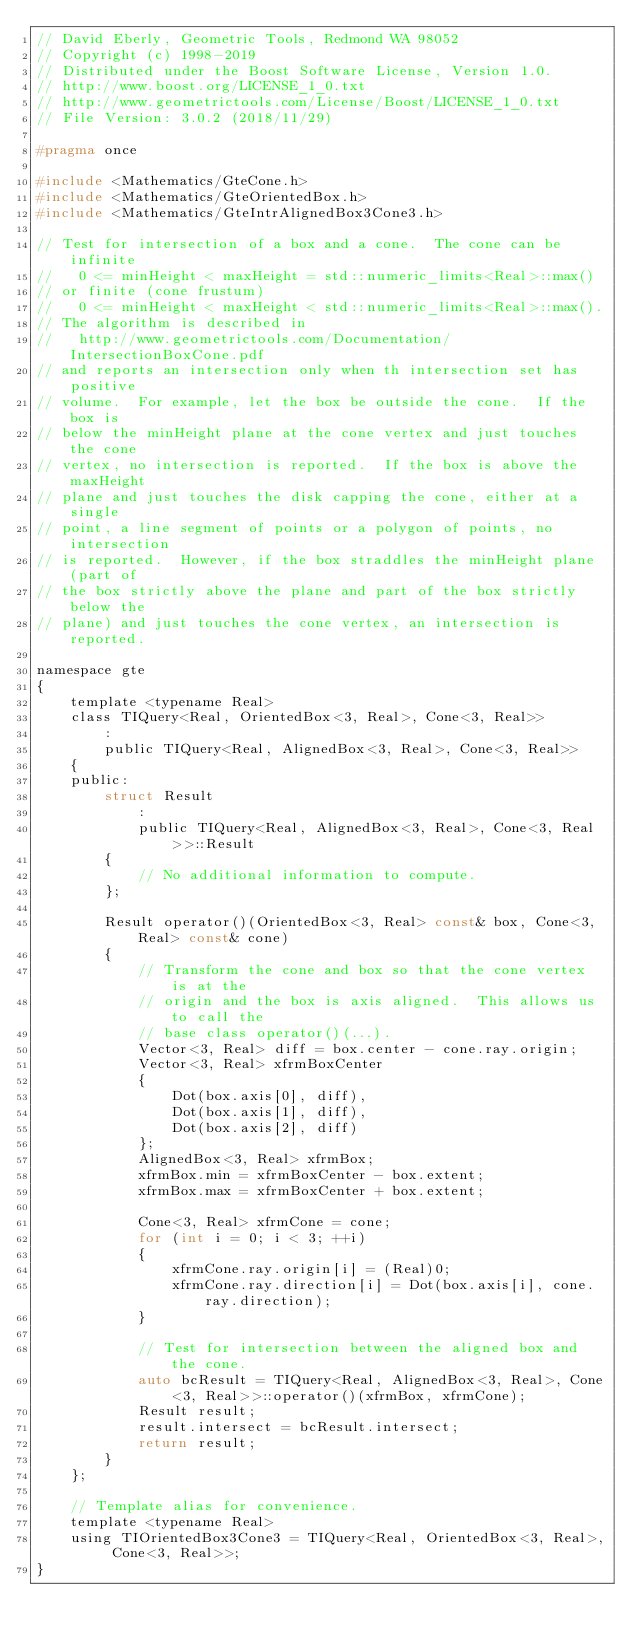<code> <loc_0><loc_0><loc_500><loc_500><_C_>// David Eberly, Geometric Tools, Redmond WA 98052
// Copyright (c) 1998-2019
// Distributed under the Boost Software License, Version 1.0.
// http://www.boost.org/LICENSE_1_0.txt
// http://www.geometrictools.com/License/Boost/LICENSE_1_0.txt
// File Version: 3.0.2 (2018/11/29)

#pragma once

#include <Mathematics/GteCone.h>
#include <Mathematics/GteOrientedBox.h>
#include <Mathematics/GteIntrAlignedBox3Cone3.h>

// Test for intersection of a box and a cone.  The cone can be infinite
//   0 <= minHeight < maxHeight = std::numeric_limits<Real>::max()
// or finite (cone frustum)
//   0 <= minHeight < maxHeight < std::numeric_limits<Real>::max().
// The algorithm is described in
//   http://www.geometrictools.com/Documentation/IntersectionBoxCone.pdf
// and reports an intersection only when th intersection set has positive
// volume.  For example, let the box be outside the cone.  If the box is
// below the minHeight plane at the cone vertex and just touches the cone
// vertex, no intersection is reported.  If the box is above the maxHeight
// plane and just touches the disk capping the cone, either at a single
// point, a line segment of points or a polygon of points, no intersection
// is reported.  However, if the box straddles the minHeight plane (part of
// the box strictly above the plane and part of the box strictly below the
// plane) and just touches the cone vertex, an intersection is reported.

namespace gte
{
    template <typename Real>
    class TIQuery<Real, OrientedBox<3, Real>, Cone<3, Real>>
        :
        public TIQuery<Real, AlignedBox<3, Real>, Cone<3, Real>>
    {
    public:
        struct Result
            :
            public TIQuery<Real, AlignedBox<3, Real>, Cone<3, Real>>::Result
        {
            // No additional information to compute.
        };

        Result operator()(OrientedBox<3, Real> const& box, Cone<3, Real> const& cone)
        {
            // Transform the cone and box so that the cone vertex is at the
            // origin and the box is axis aligned.  This allows us to call the
            // base class operator()(...).
            Vector<3, Real> diff = box.center - cone.ray.origin;
            Vector<3, Real> xfrmBoxCenter
            {
                Dot(box.axis[0], diff),
                Dot(box.axis[1], diff),
                Dot(box.axis[2], diff)
            };
            AlignedBox<3, Real> xfrmBox;
            xfrmBox.min = xfrmBoxCenter - box.extent;
            xfrmBox.max = xfrmBoxCenter + box.extent;

            Cone<3, Real> xfrmCone = cone;
            for (int i = 0; i < 3; ++i)
            {
                xfrmCone.ray.origin[i] = (Real)0;
                xfrmCone.ray.direction[i] = Dot(box.axis[i], cone.ray.direction);
            }

            // Test for intersection between the aligned box and the cone.
            auto bcResult = TIQuery<Real, AlignedBox<3, Real>, Cone<3, Real>>::operator()(xfrmBox, xfrmCone);
            Result result;
            result.intersect = bcResult.intersect;
            return result;
        }
    };

    // Template alias for convenience.
    template <typename Real>
    using TIOrientedBox3Cone3 = TIQuery<Real, OrientedBox<3, Real>, Cone<3, Real>>;
}
</code> 